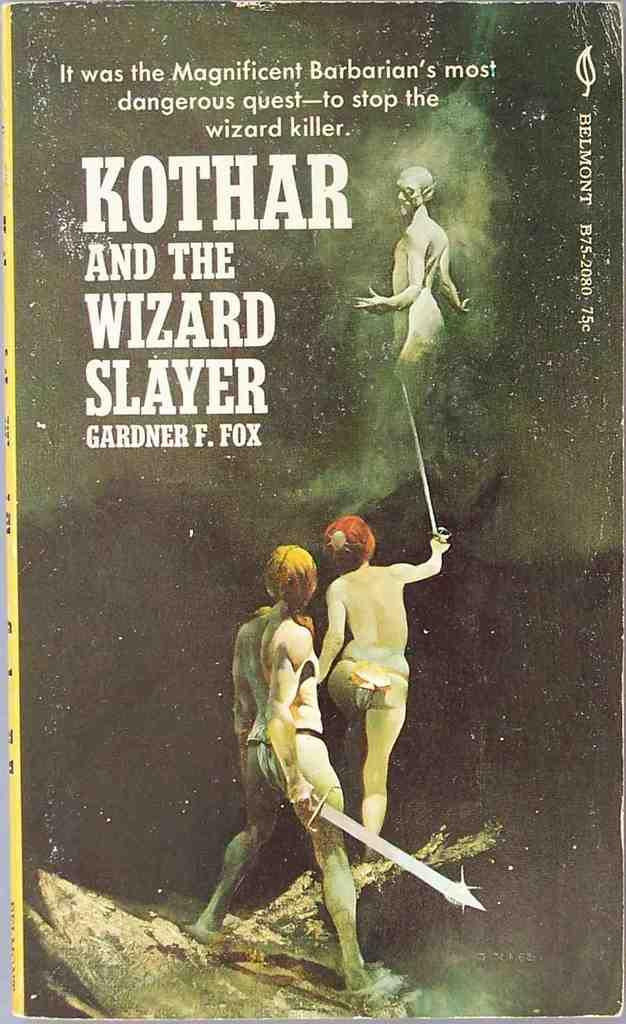What is present in the image that has words on it? There is a poster in the image with words on it. What specific words can be seen on the poster? The poster has the words "Gardner f. fox" written on it. How deep is the ocean in the image? There is no ocean present in the image; it only features a poster with the words "Gardner f. fox" on it. 